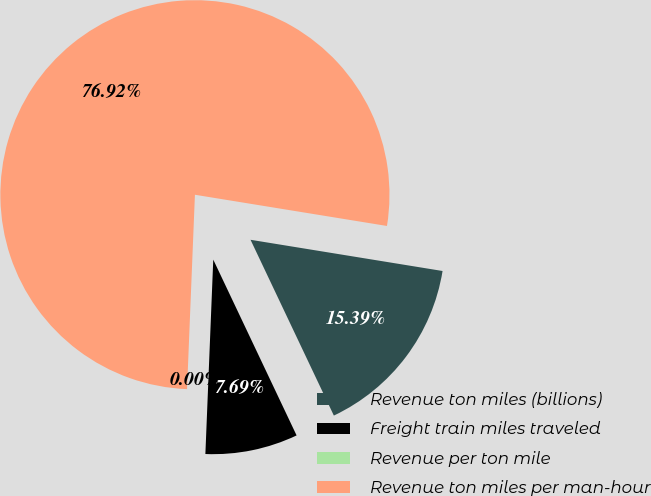Convert chart. <chart><loc_0><loc_0><loc_500><loc_500><pie_chart><fcel>Revenue ton miles (billions)<fcel>Freight train miles traveled<fcel>Revenue per ton mile<fcel>Revenue ton miles per man-hour<nl><fcel>15.39%<fcel>7.69%<fcel>0.0%<fcel>76.92%<nl></chart> 